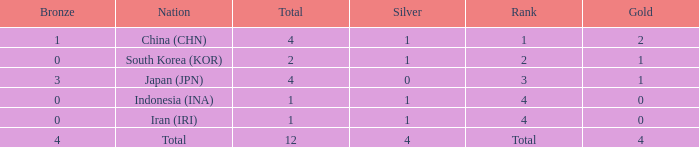How many silver medals for the nation with fewer than 1 golds and total less than 1? 0.0. Could you parse the entire table? {'header': ['Bronze', 'Nation', 'Total', 'Silver', 'Rank', 'Gold'], 'rows': [['1', 'China (CHN)', '4', '1', '1', '2'], ['0', 'South Korea (KOR)', '2', '1', '2', '1'], ['3', 'Japan (JPN)', '4', '0', '3', '1'], ['0', 'Indonesia (INA)', '1', '1', '4', '0'], ['0', 'Iran (IRI)', '1', '1', '4', '0'], ['4', 'Total', '12', '4', 'Total', '4']]} 